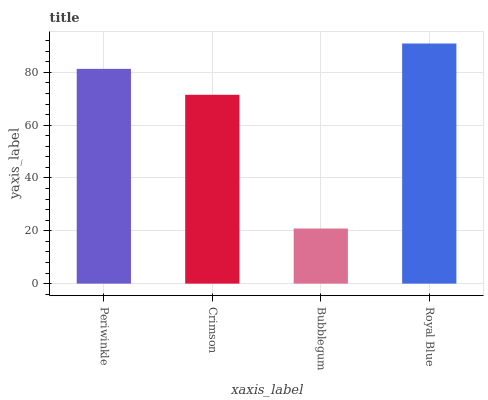Is Bubblegum the minimum?
Answer yes or no. Yes. Is Royal Blue the maximum?
Answer yes or no. Yes. Is Crimson the minimum?
Answer yes or no. No. Is Crimson the maximum?
Answer yes or no. No. Is Periwinkle greater than Crimson?
Answer yes or no. Yes. Is Crimson less than Periwinkle?
Answer yes or no. Yes. Is Crimson greater than Periwinkle?
Answer yes or no. No. Is Periwinkle less than Crimson?
Answer yes or no. No. Is Periwinkle the high median?
Answer yes or no. Yes. Is Crimson the low median?
Answer yes or no. Yes. Is Royal Blue the high median?
Answer yes or no. No. Is Royal Blue the low median?
Answer yes or no. No. 